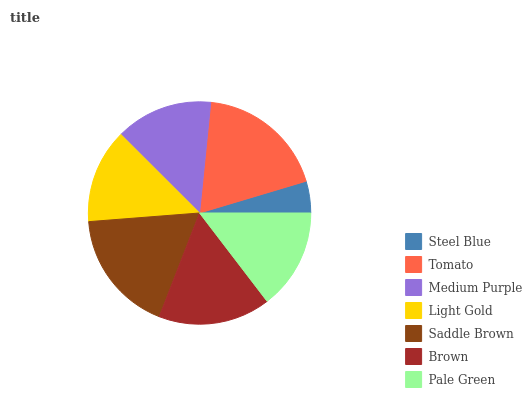Is Steel Blue the minimum?
Answer yes or no. Yes. Is Tomato the maximum?
Answer yes or no. Yes. Is Medium Purple the minimum?
Answer yes or no. No. Is Medium Purple the maximum?
Answer yes or no. No. Is Tomato greater than Medium Purple?
Answer yes or no. Yes. Is Medium Purple less than Tomato?
Answer yes or no. Yes. Is Medium Purple greater than Tomato?
Answer yes or no. No. Is Tomato less than Medium Purple?
Answer yes or no. No. Is Pale Green the high median?
Answer yes or no. Yes. Is Pale Green the low median?
Answer yes or no. Yes. Is Medium Purple the high median?
Answer yes or no. No. Is Medium Purple the low median?
Answer yes or no. No. 